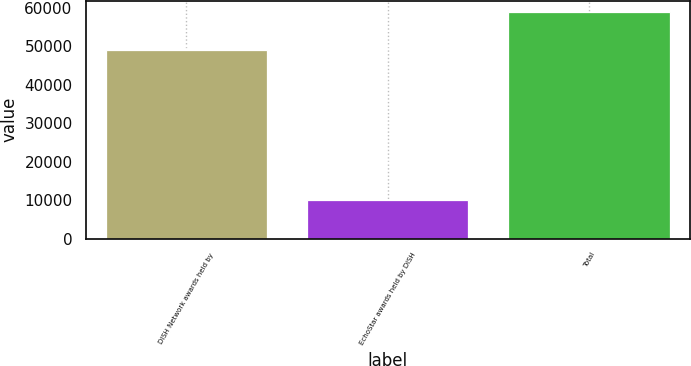Convert chart. <chart><loc_0><loc_0><loc_500><loc_500><bar_chart><fcel>DISH Network awards held by<fcel>EchoStar awards held by DISH<fcel>Total<nl><fcel>49039<fcel>9957<fcel>58996<nl></chart> 